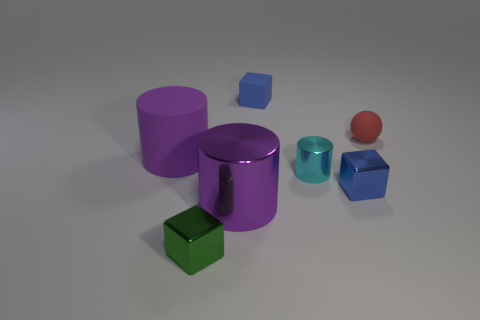There is a tiny metal cube that is behind the small object that is left of the purple metallic thing; what is its color?
Provide a succinct answer. Blue. How many other objects are the same material as the sphere?
Make the answer very short. 2. What number of other things are the same color as the large shiny object?
Provide a short and direct response. 1. What is the material of the cube that is behind the tiny metallic cube on the right side of the green object?
Your response must be concise. Rubber. Is there a small blue shiny cube?
Keep it short and to the point. Yes. There is a blue thing behind the purple cylinder that is to the left of the tiny green metal cube; what size is it?
Provide a short and direct response. Small. Is the number of tiny red balls to the left of the blue matte thing greater than the number of blue metallic blocks in front of the purple matte object?
Your response must be concise. No. How many cylinders are either purple objects or green metal objects?
Your answer should be compact. 2. Are there any other things that are the same size as the green shiny thing?
Offer a terse response. Yes. There is a purple thing on the right side of the green metal cube; does it have the same shape as the cyan metal object?
Your answer should be very brief. Yes. 